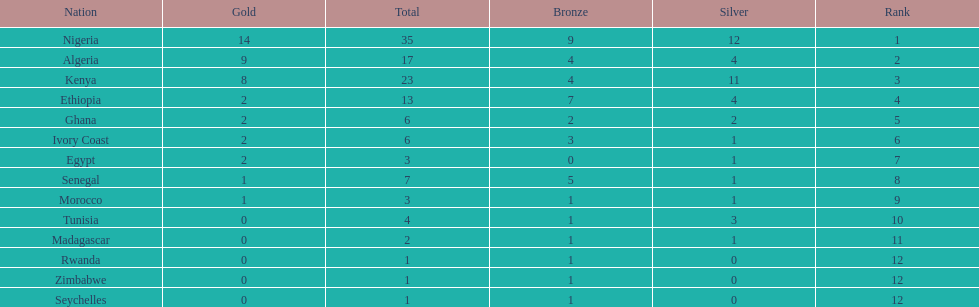The country that won the most medals was? Nigeria. Parse the table in full. {'header': ['Nation', 'Gold', 'Total', 'Bronze', 'Silver', 'Rank'], 'rows': [['Nigeria', '14', '35', '9', '12', '1'], ['Algeria', '9', '17', '4', '4', '2'], ['Kenya', '8', '23', '4', '11', '3'], ['Ethiopia', '2', '13', '7', '4', '4'], ['Ghana', '2', '6', '2', '2', '5'], ['Ivory Coast', '2', '6', '3', '1', '6'], ['Egypt', '2', '3', '0', '1', '7'], ['Senegal', '1', '7', '5', '1', '8'], ['Morocco', '1', '3', '1', '1', '9'], ['Tunisia', '0', '4', '1', '3', '10'], ['Madagascar', '0', '2', '1', '1', '11'], ['Rwanda', '0', '1', '1', '0', '12'], ['Zimbabwe', '0', '1', '1', '0', '12'], ['Seychelles', '0', '1', '1', '0', '12']]} 